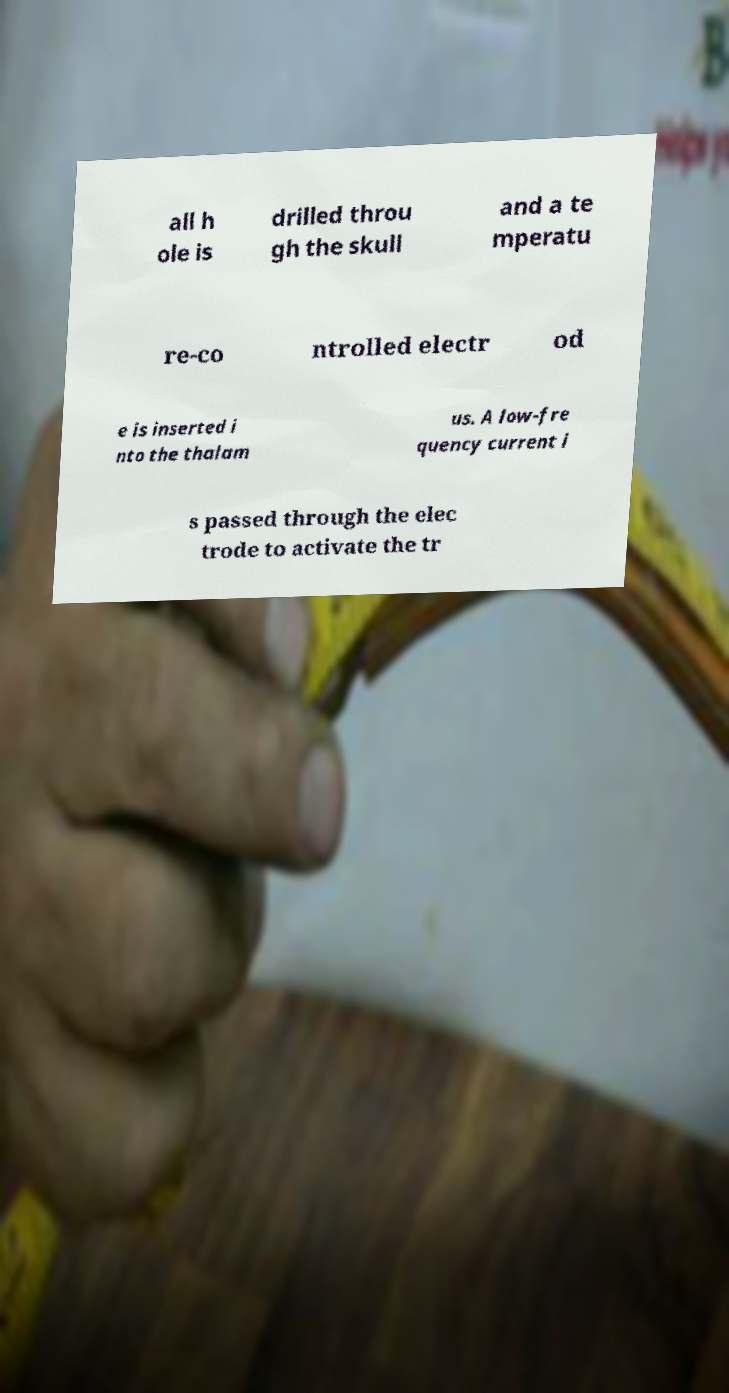Please read and relay the text visible in this image. What does it say? all h ole is drilled throu gh the skull and a te mperatu re-co ntrolled electr od e is inserted i nto the thalam us. A low-fre quency current i s passed through the elec trode to activate the tr 